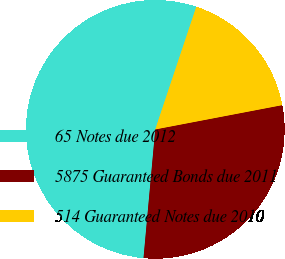Convert chart. <chart><loc_0><loc_0><loc_500><loc_500><pie_chart><fcel>65 Notes due 2012<fcel>5875 Guaranteed Bonds due 2011<fcel>514 Guaranteed Notes due 2010<nl><fcel>53.69%<fcel>29.46%<fcel>16.85%<nl></chart> 